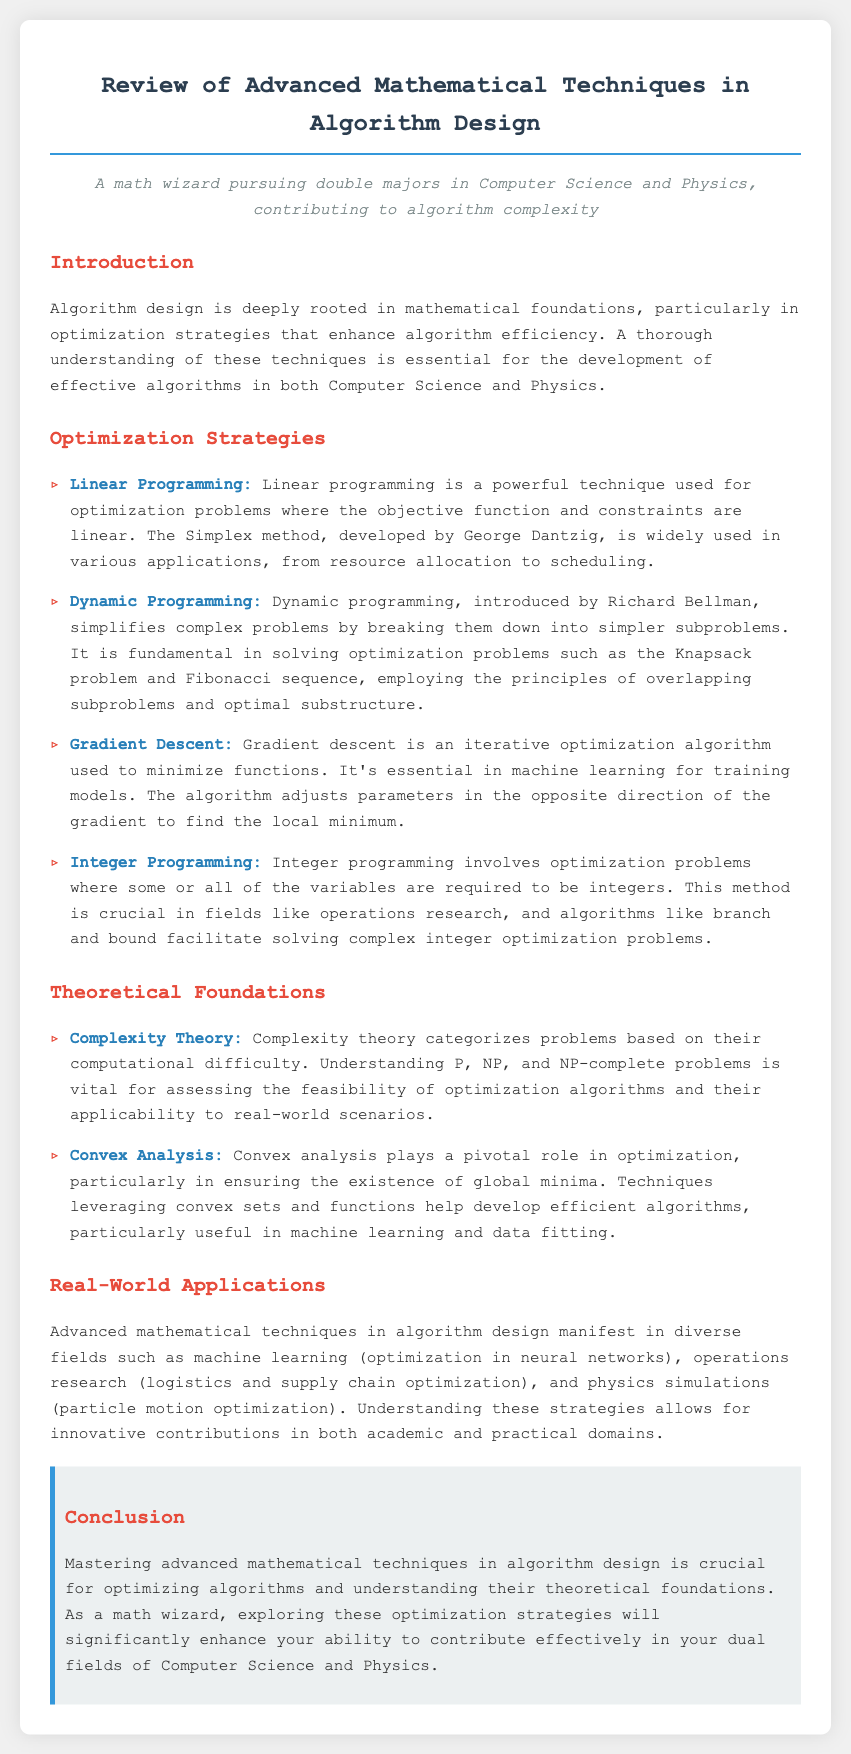What is the main focus of the memo? The main focus of the memo is the review of advanced mathematical techniques in algorithm design, with an emphasis on optimization strategies and their theoretical foundations.
Answer: advanced mathematical techniques in algorithm design Who developed the Simplex method? The Simplex method, used in linear programming, was developed by George Dantzig.
Answer: George Dantzig What problem does Dynamic Programming fundamentally address? Dynamic programming simplifies complex problems, particularly in solving optimization problems like the Knapsack problem.
Answer: Knapsack problem Which optimization algorithm is used to minimize functions in machine learning? Gradient descent is an iterative optimization algorithm used to minimize functions and is essential in machine learning.
Answer: Gradient descent What fundamental classification is discussed in Complexity Theory? Complexity theory categorizes problems based on their computational difficulty, particularly focusing on P, NP, and NP-complete problems.
Answer: P, NP, NP-complete What area does Convex Analysis primarily relate to? Convex analysis is crucial in optimization, especially in ensuring the existence of global minima.
Answer: optimization In which fields do advanced mathematical techniques find real-world applications? The document states applications in machine learning, operations research, and physics simulations.
Answer: machine learning, operations research, physics simulations What does the conclusion emphasize is crucial for contributing effectively in Computer Science and Physics? The conclusion emphasizes mastering advanced mathematical techniques in algorithm design for effective contributions.
Answer: mastering advanced mathematical techniques 